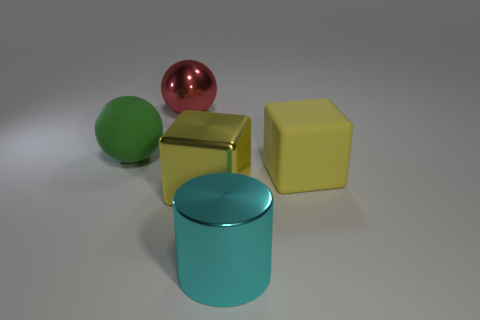Subtract all red spheres. How many spheres are left? 1 Subtract all spheres. How many objects are left? 3 Subtract 1 cubes. How many cubes are left? 1 Subtract all green spheres. Subtract all cyan cylinders. How many spheres are left? 1 Subtract all red blocks. How many green spheres are left? 1 Subtract all big red metal balls. Subtract all metallic blocks. How many objects are left? 3 Add 4 big green balls. How many big green balls are left? 5 Add 5 green matte blocks. How many green matte blocks exist? 5 Add 1 purple spheres. How many objects exist? 6 Subtract 0 brown blocks. How many objects are left? 5 